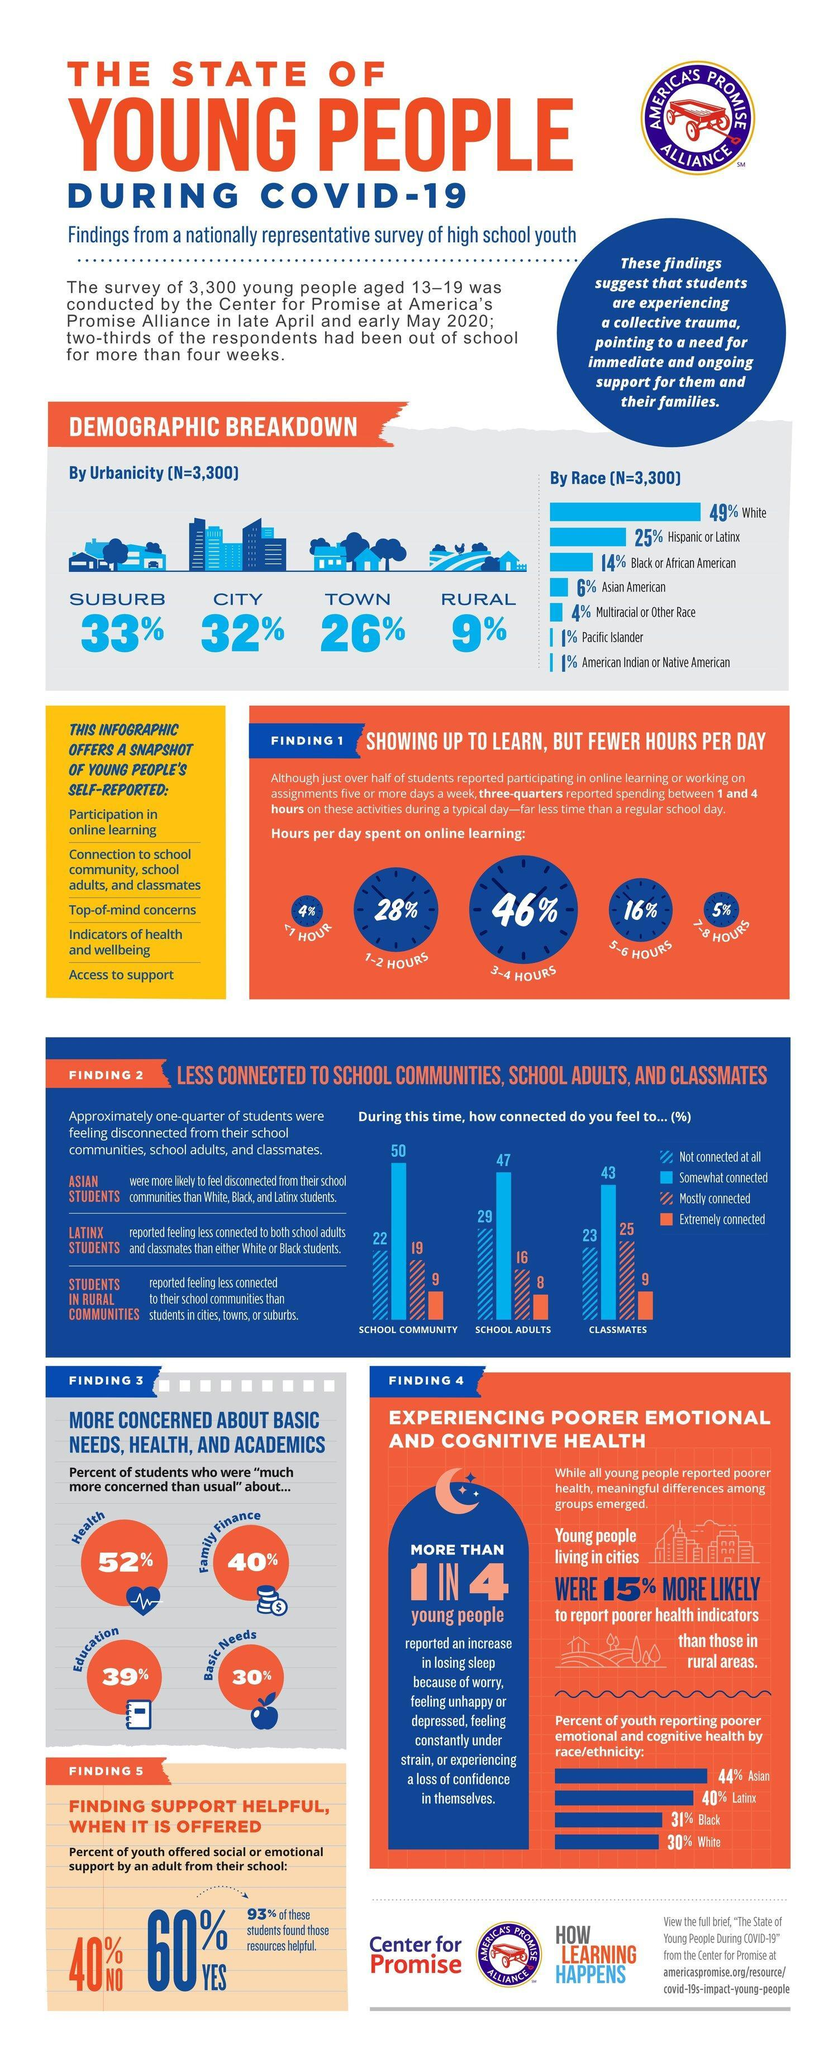What percent of American students spend 1-2 hours per day on online learning during COVID-19 as per the survey?
Answer the question with a short phrase. 28% What percent of students in America spend 3-4 hours per day on online learning during COVID-19 according to the survey? 46% What percent of students in America were much more concerned than usual about their health during COVID-19 according to the survey? 52% What percent of students in America spend 7-8 hours per day on online learning during COVID-19 as per the survey? 5% What percent of students in America felt mostly connected to their classmates during COVID-19 as per the survey? 25 What percent of students in America felt extremely connected to their classmates during COVID-19 as per the survey? 9 What percent of students in America were much more concerned than usual about their basic needs during COVID-19 as per the survey? 30% What percent of students in America felt not at all connected to their school community during COVID-19 as per the survey? 22 What percent of black youths in America reported poorer emotional & cognitive health during COVID-19 according to the survey? 31% What percent of students in America were much more concerned than usual about the family finance during COVID-19 according to the survey? 40% 